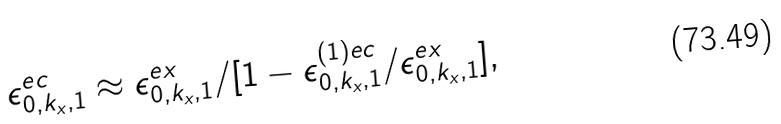Convert formula to latex. <formula><loc_0><loc_0><loc_500><loc_500>\epsilon ^ { e c } _ { 0 , k _ { x } , 1 } \approx \epsilon ^ { e x } _ { 0 , k _ { x } , 1 } / [ 1 - \epsilon ^ { ( 1 ) e c } _ { 0 , k _ { x } , 1 } / \epsilon ^ { e x } _ { 0 , k _ { x } , 1 } ] ,</formula> 